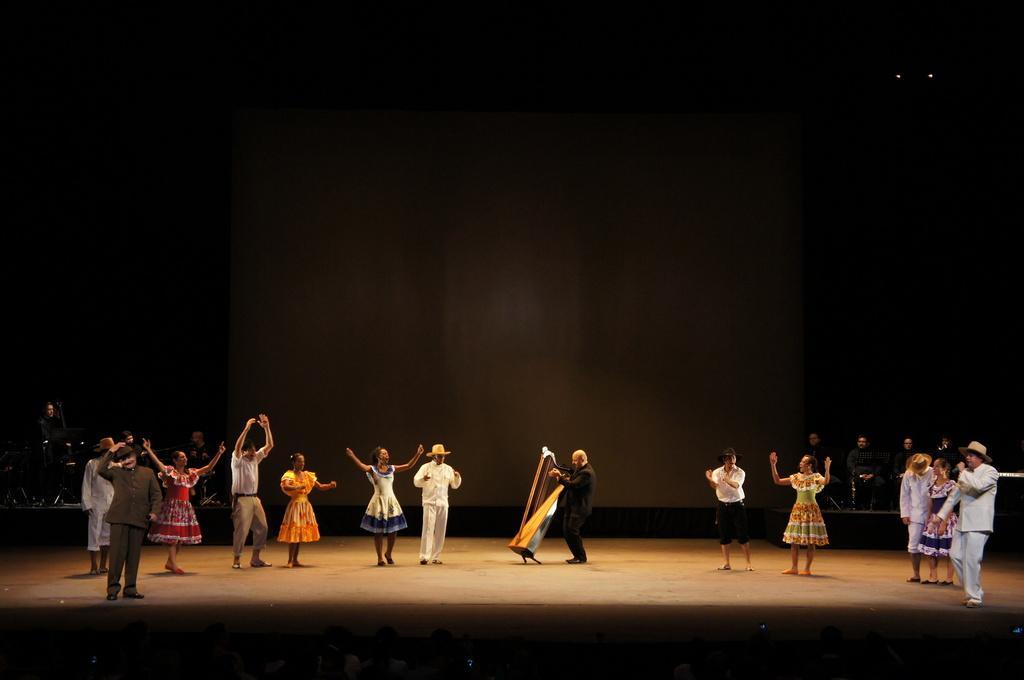Could you give a brief overview of what you see in this image? In the foreground of this image, there are persons standing on the stage and a man playing musical instrument. In the background, there is a screen, few persons sitting and standing in the dark background. 